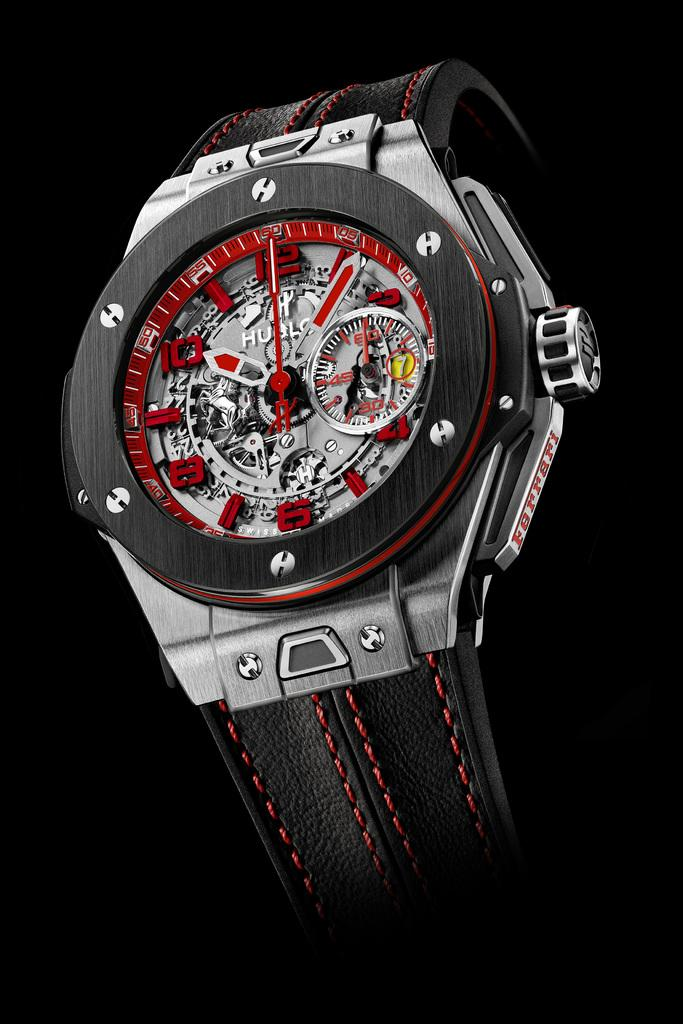<image>
Offer a succinct explanation of the picture presented. the hublo watch is black, silver and red 